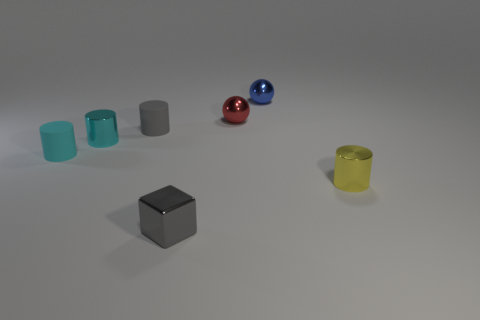The small metal object that is in front of the small metallic cylinder right of the gray matte thing is what shape?
Provide a short and direct response. Cube. How many things are tiny gray things behind the gray shiny object or gray things that are behind the tiny gray shiny object?
Your answer should be very brief. 1. The cyan thing that is the same material as the small yellow thing is what shape?
Keep it short and to the point. Cylinder. There is another tiny cyan thing that is the same shape as the tiny cyan rubber object; what is it made of?
Offer a terse response. Metal. What material is the gray cylinder?
Offer a terse response. Rubber. There is a shiny cylinder to the left of the block; is it the same color as the tiny matte thing left of the cyan metal cylinder?
Offer a terse response. Yes. There is a small object that is to the left of the tiny shiny block and right of the cyan metallic object; what shape is it?
Keep it short and to the point. Cylinder. Are there the same number of tiny cyan things that are in front of the small yellow metal cylinder and gray matte things to the left of the tiny blue metallic thing?
Provide a short and direct response. No. Are there any yellow cylinders made of the same material as the gray cube?
Offer a very short reply. Yes. Is the material of the cylinder that is right of the red shiny ball the same as the gray cylinder?
Keep it short and to the point. No. 